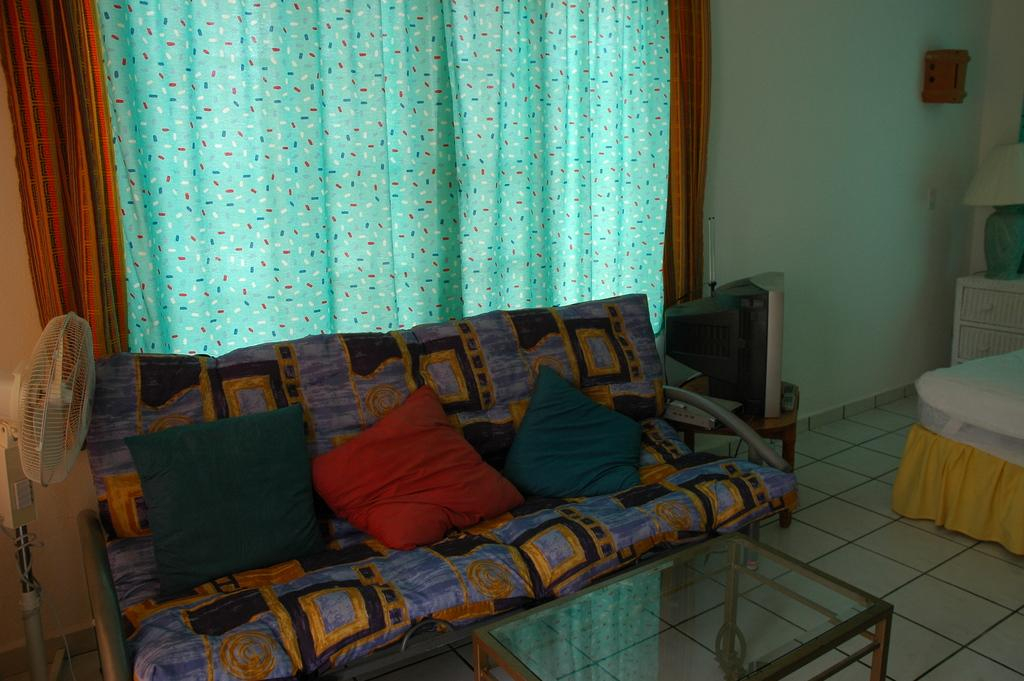What type of seating is available in the room? There is a sofa with cushions in the room. What is used for cooling in the room? There is a table fan in the room. What piece of furniture is present for placing items? There is a table in the room. What electronic device is in the room for entertainment? There is a TV in the room. Can you tell me how many robins are sitting on the TV in the image? There are no robins present in the image; it only features a sofa, table fan, table, and TV. What type of game is being played on the table in the image? There is no game being played on the table in the image; it is a regular table with no visible activity. 